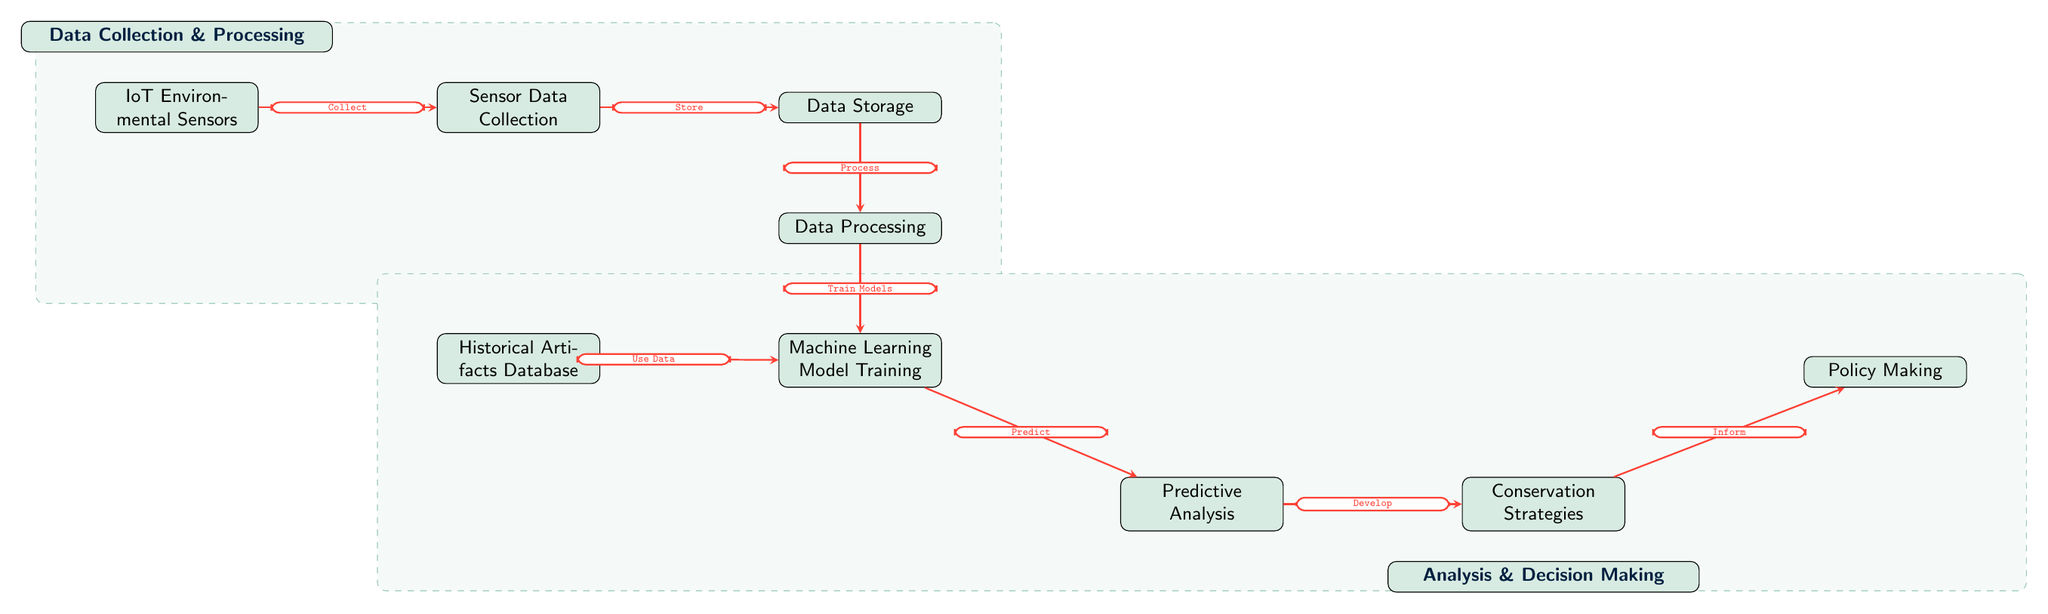What is the first node in the diagram? The first node in the diagram is labeled "IoT Environmental Sensors." It is the starting point of the flow that leads to data collection.
Answer: IoT Environmental Sensors How many edges connect to the "Data Processing" node? The "Data Processing" node has one incoming edge from "Data Storage" and one outgoing edge to "Machine Learning Model Training," resulting in a total of two edges connected to it.
Answer: 2 What task follows after "Predictive Analysis"? After "Predictive Analysis," the next task is "Conservation Strategies." This is the immediate next node connected by an edge.
Answer: Conservation Strategies What does the "Historical Artifacts Database" contribute to? The "Historical Artifacts Database" contributes data to the "Machine Learning Model Training" node, indicated by the edge that directly connects them.
Answer: Machine Learning Model Training How does "Machine Learning Model Training" utilize data from the "Historical Artifacts Database"? "Machine Learning Model Training" uses data from the "Historical Artifacts Database" to develop predictive models, as indicated by the edge labeled "Use Data."
Answer: Use Data What is the relationship between "Conservation Strategies" and "Policy Making"? "Conservation Strategies" informs "Policy Making," as shown by the edge connecting these two nodes, indicating a directional flow from conservation efforts to policy decisions.
Answer: Inform Which two nodes are connected directly by the same edge? The nodes "Predictive Analysis" and "Conservation Strategies" are connected directly by the edge labeled "Develop," indicating a clear and singular relationship between them.
Answer: Develop What type of analysis is shown in the diagram's second half? The second half of the diagram focuses on "Analysis & Decision Making," emphasizing the significance of analysis following data processing and model training.
Answer: Analysis & Decision Making 